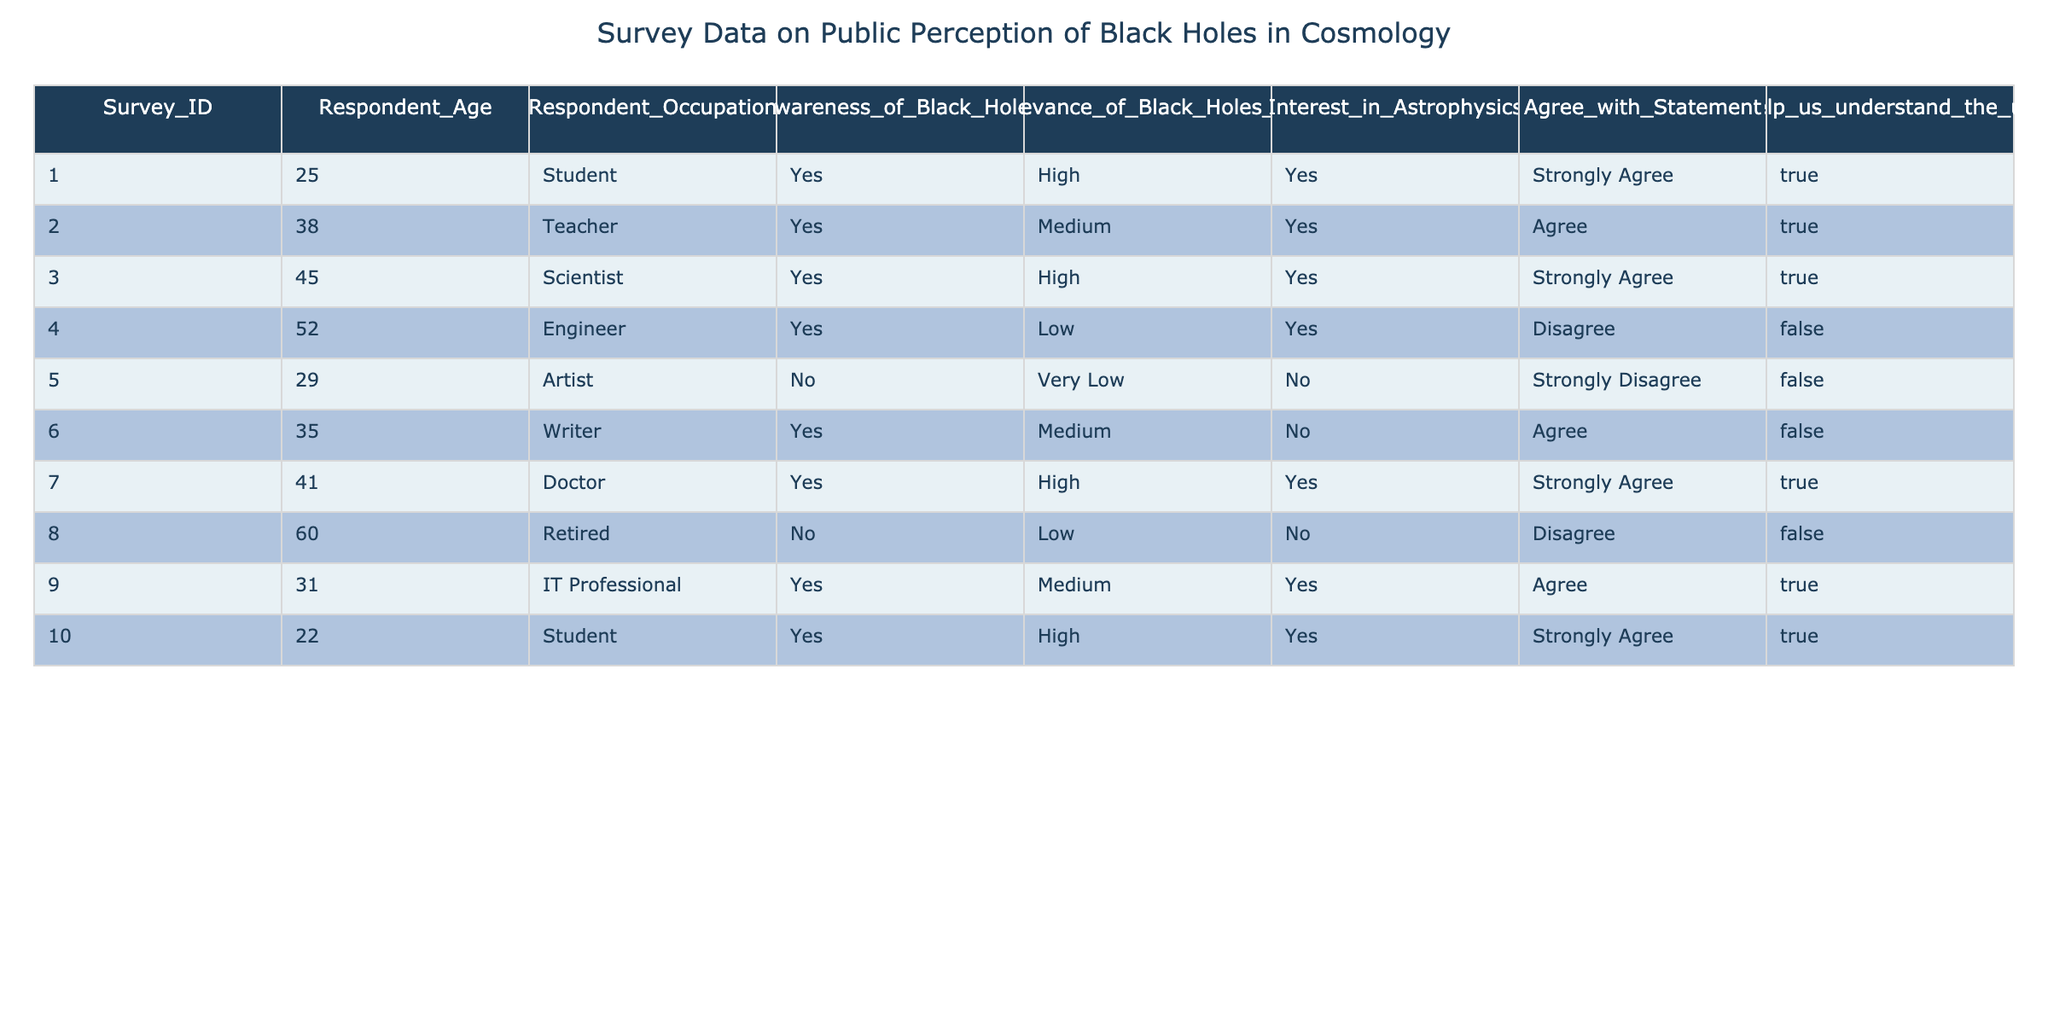What is the perceived relevance of black holes in cosmology among respondents aged 25? The table shows that there is one respondent aged 25, and their perceived relevance is "High."
Answer: High How many respondents agree or strongly agree with the statement that black holes help us understand the universe better? Examining the table, the respondents who agree or strongly agree with that statement are IDs 1, 2, 3, 7, 9, and 10. That totals to 6 respondents.
Answer: 6 What is the average age of respondents who are interested in astrophysics? Only IDs 1, 2, 3, 7, and 9 have a "Yes" for interest in astrophysics. Their ages are 25, 38, 45, 41, and 31. The average is calculated as (25 + 38 + 45 + 41 + 31) / 5 = 36.
Answer: 36 Do any retired respondents perceive the relevance of black holes in cosmology as "High"? The table shows that there is one retired respondent, ID 8, whose perceived relevance is "Low." Therefore, no retired respondents perceive it as "High."
Answer: No Which occupation group has the highest representation among respondents who disagree with the statement about black holes? The table shows that there are two respondents who disagreed, IDs 4 and 6. ID 4 is an Engineer, and ID 6 is a Writer. Therefore, the occupation group with the highest representation is both Engineer and Writer, each with 1 response.
Answer: Engineer and Writer What percentage of respondents aged 60 or older believe that black holes help us understand the universe better? There is one respondent aged 60 (ID 8), who disagrees with the statement about understanding. Thus, the percentage is (0 / 1) * 100 = 0%.
Answer: 0% How many respondents perceive the relevance of black holes as "Very Low"? There is one respondent, ID 5, who perceives the relevance of black holes as "Very Low."
Answer: 1 What is the most common level of perceived relevance of black holes among respondents? Analyzing the table, we see "High" appears most frequently, with respondents 1, 3, 7, and 10, totaling 4 instances.
Answer: High What is the relationship between occupation and the perceived relevance of black holes, based on the data? The table shows varying responses among different occupations. For instance, Scientists and Students (ID 1, 3, 10) tend to perceive it as "High," whereas an Engineer perceives it as "Low," and a Teacher rates it "Medium." This indicates that scientists and students generally find black holes more relevant than engineers or artists.
Answer: Scientists and Students find it more relevant 